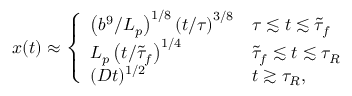<formula> <loc_0><loc_0><loc_500><loc_500>x ( t ) \approx \left \{ \begin{array} { l l } { \left ( { b ^ { 9 } } / { L _ { p } } \right ) ^ { 1 / 8 } \left ( t / { \tau } \right ) ^ { 3 / 8 } } & { \tau \lesssim t \lesssim \tilde { \tau } _ { f } } \\ { L _ { p } \left ( t / { \tilde { \tau } _ { f } } \right ) ^ { 1 / 4 } } & { \tilde { \tau } _ { f } \lesssim t \lesssim \tau _ { R } } \\ { ( D t ) ^ { 1 / 2 } } & { t \gtrsim \tau _ { R } , } \end{array}</formula> 